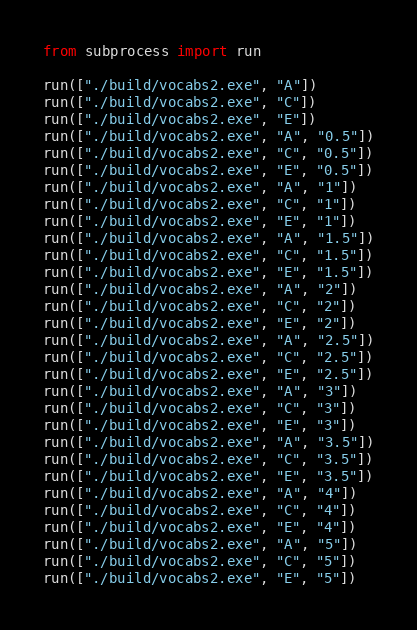Convert code to text. <code><loc_0><loc_0><loc_500><loc_500><_Python_>from subprocess import run

run(["./build/vocabs2.exe", "A"])
run(["./build/vocabs2.exe", "C"])
run(["./build/vocabs2.exe", "E"])
run(["./build/vocabs2.exe", "A", "0.5"])
run(["./build/vocabs2.exe", "C", "0.5"])
run(["./build/vocabs2.exe", "E", "0.5"])
run(["./build/vocabs2.exe", "A", "1"])
run(["./build/vocabs2.exe", "C", "1"])
run(["./build/vocabs2.exe", "E", "1"])
run(["./build/vocabs2.exe", "A", "1.5"])
run(["./build/vocabs2.exe", "C", "1.5"])
run(["./build/vocabs2.exe", "E", "1.5"])
run(["./build/vocabs2.exe", "A", "2"])
run(["./build/vocabs2.exe", "C", "2"])
run(["./build/vocabs2.exe", "E", "2"])
run(["./build/vocabs2.exe", "A", "2.5"])
run(["./build/vocabs2.exe", "C", "2.5"])
run(["./build/vocabs2.exe", "E", "2.5"])
run(["./build/vocabs2.exe", "A", "3"])
run(["./build/vocabs2.exe", "C", "3"])
run(["./build/vocabs2.exe", "E", "3"])
run(["./build/vocabs2.exe", "A", "3.5"])
run(["./build/vocabs2.exe", "C", "3.5"])
run(["./build/vocabs2.exe", "E", "3.5"])
run(["./build/vocabs2.exe", "A", "4"])
run(["./build/vocabs2.exe", "C", "4"])
run(["./build/vocabs2.exe", "E", "4"])
run(["./build/vocabs2.exe", "A", "5"])
run(["./build/vocabs2.exe", "C", "5"])
run(["./build/vocabs2.exe", "E", "5"])
</code> 